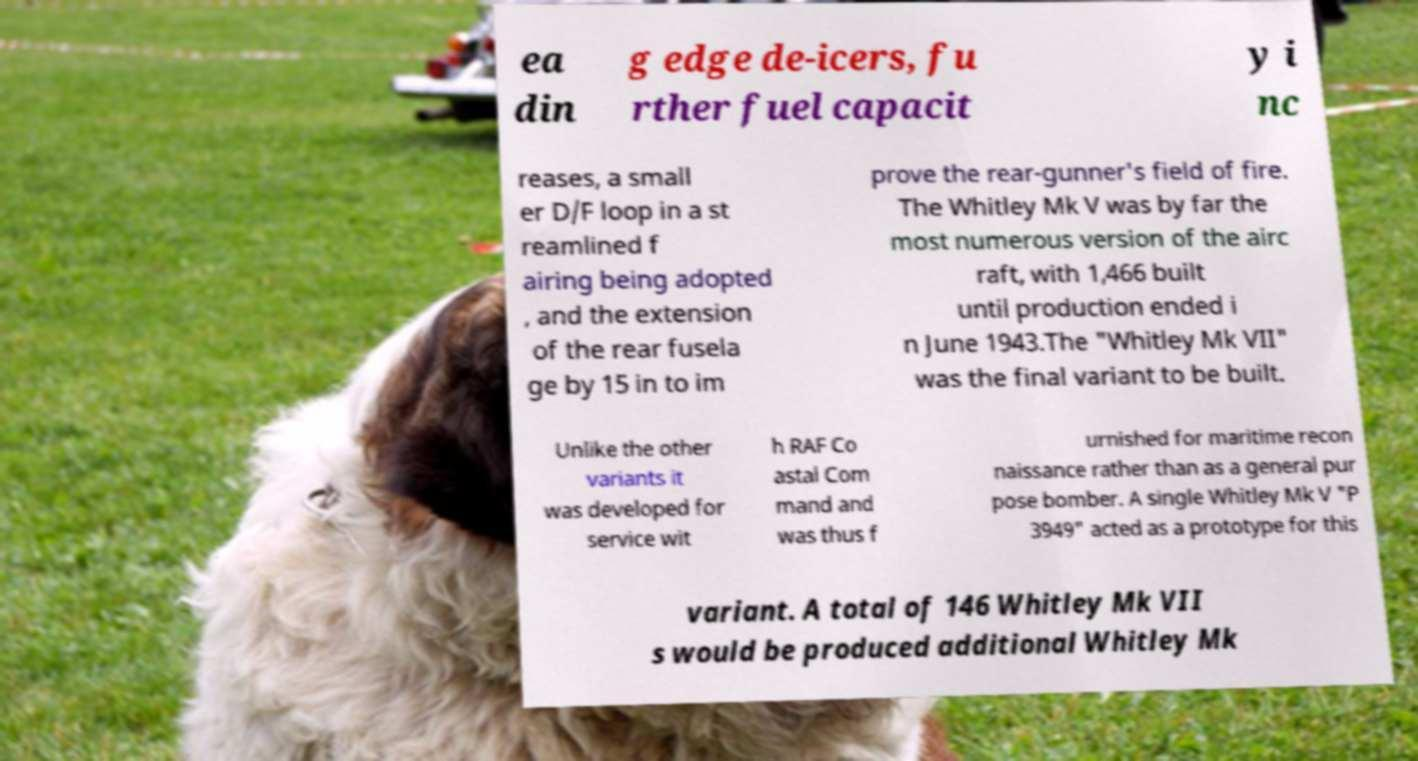Please identify and transcribe the text found in this image. ea din g edge de-icers, fu rther fuel capacit y i nc reases, a small er D/F loop in a st reamlined f airing being adopted , and the extension of the rear fusela ge by 15 in to im prove the rear-gunner's field of fire. The Whitley Mk V was by far the most numerous version of the airc raft, with 1,466 built until production ended i n June 1943.The "Whitley Mk VII" was the final variant to be built. Unlike the other variants it was developed for service wit h RAF Co astal Com mand and was thus f urnished for maritime recon naissance rather than as a general pur pose bomber. A single Whitley Mk V "P 3949" acted as a prototype for this variant. A total of 146 Whitley Mk VII s would be produced additional Whitley Mk 